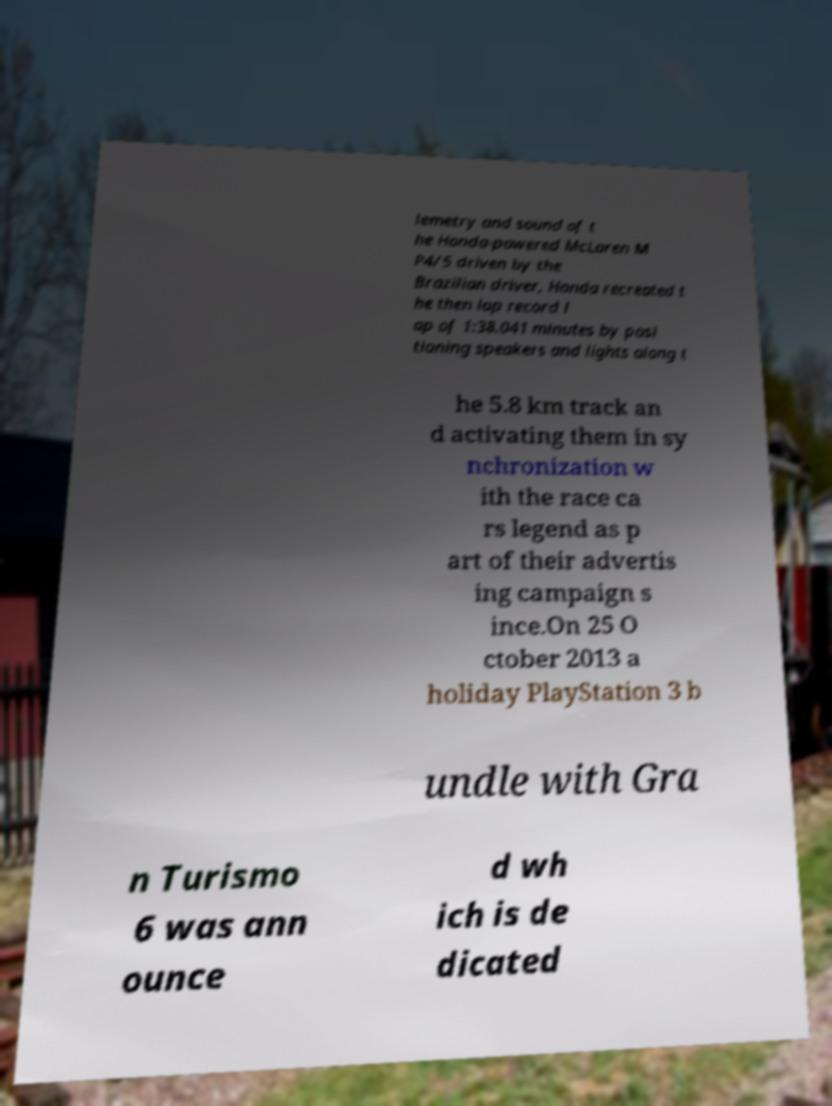Please identify and transcribe the text found in this image. lemetry and sound of t he Honda-powered McLaren M P4/5 driven by the Brazilian driver, Honda recreated t he then lap record l ap of 1:38.041 minutes by posi tioning speakers and lights along t he 5.8 km track an d activating them in sy nchronization w ith the race ca rs legend as p art of their advertis ing campaign s ince.On 25 O ctober 2013 a holiday PlayStation 3 b undle with Gra n Turismo 6 was ann ounce d wh ich is de dicated 